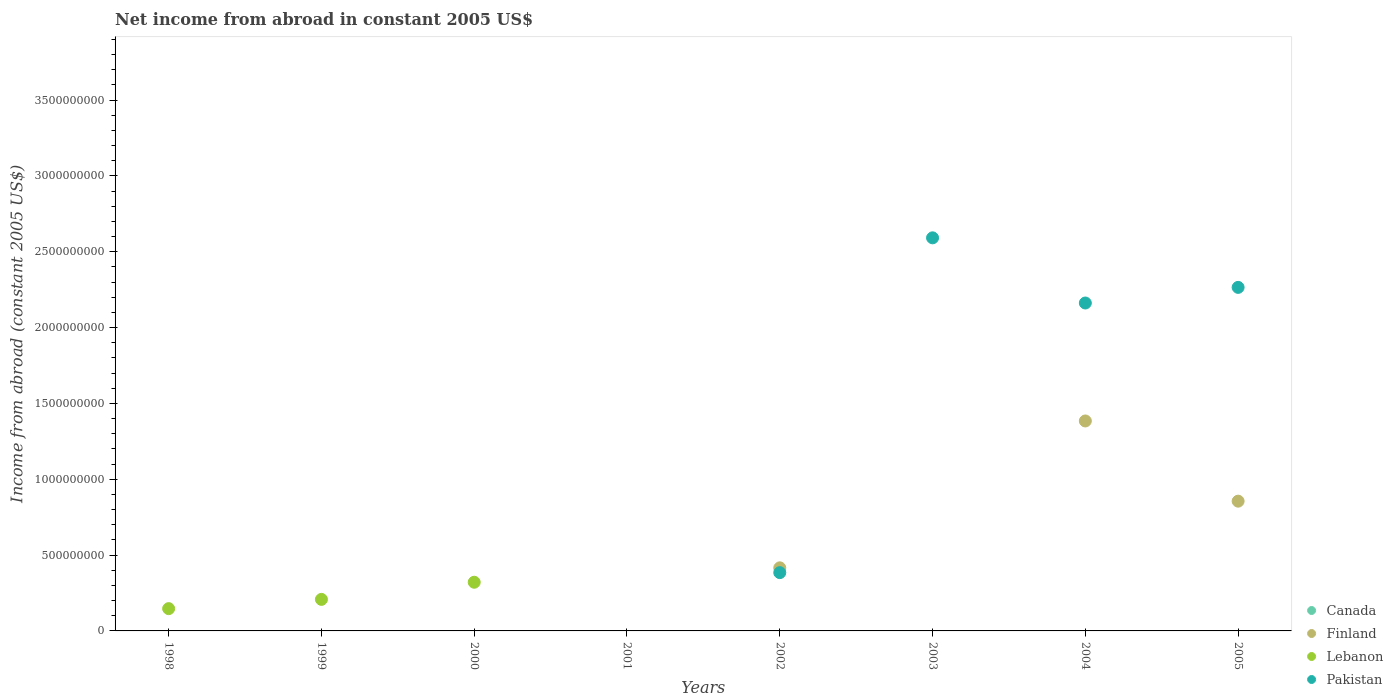How many different coloured dotlines are there?
Give a very brief answer. 3. Across all years, what is the maximum net income from abroad in Lebanon?
Provide a short and direct response. 3.21e+08. In which year was the net income from abroad in Lebanon maximum?
Make the answer very short. 2000. What is the difference between the net income from abroad in Canada in 2003 and the net income from abroad in Lebanon in 2001?
Offer a very short reply. 0. What is the average net income from abroad in Lebanon per year?
Provide a succinct answer. 8.45e+07. In the year 2005, what is the difference between the net income from abroad in Finland and net income from abroad in Pakistan?
Your response must be concise. -1.41e+09. Is the difference between the net income from abroad in Finland in 2002 and 2004 greater than the difference between the net income from abroad in Pakistan in 2002 and 2004?
Your response must be concise. Yes. What is the difference between the highest and the second highest net income from abroad in Lebanon?
Your answer should be compact. 1.13e+08. What is the difference between the highest and the lowest net income from abroad in Lebanon?
Ensure brevity in your answer.  3.21e+08. Is the net income from abroad in Pakistan strictly greater than the net income from abroad in Lebanon over the years?
Make the answer very short. No. Is the net income from abroad in Pakistan strictly less than the net income from abroad in Lebanon over the years?
Keep it short and to the point. No. How many years are there in the graph?
Your response must be concise. 8. What is the difference between two consecutive major ticks on the Y-axis?
Keep it short and to the point. 5.00e+08. Are the values on the major ticks of Y-axis written in scientific E-notation?
Make the answer very short. No. Does the graph contain grids?
Provide a succinct answer. No. How many legend labels are there?
Ensure brevity in your answer.  4. How are the legend labels stacked?
Give a very brief answer. Vertical. What is the title of the graph?
Your answer should be very brief. Net income from abroad in constant 2005 US$. Does "Niger" appear as one of the legend labels in the graph?
Your response must be concise. No. What is the label or title of the Y-axis?
Give a very brief answer. Income from abroad (constant 2005 US$). What is the Income from abroad (constant 2005 US$) in Lebanon in 1998?
Offer a very short reply. 1.47e+08. What is the Income from abroad (constant 2005 US$) of Canada in 1999?
Offer a terse response. 0. What is the Income from abroad (constant 2005 US$) of Finland in 1999?
Give a very brief answer. 0. What is the Income from abroad (constant 2005 US$) of Lebanon in 1999?
Provide a succinct answer. 2.08e+08. What is the Income from abroad (constant 2005 US$) of Pakistan in 1999?
Your answer should be very brief. 0. What is the Income from abroad (constant 2005 US$) in Lebanon in 2000?
Ensure brevity in your answer.  3.21e+08. What is the Income from abroad (constant 2005 US$) in Canada in 2001?
Ensure brevity in your answer.  0. What is the Income from abroad (constant 2005 US$) of Finland in 2001?
Offer a terse response. 0. What is the Income from abroad (constant 2005 US$) of Lebanon in 2001?
Provide a short and direct response. 0. What is the Income from abroad (constant 2005 US$) in Finland in 2002?
Ensure brevity in your answer.  4.16e+08. What is the Income from abroad (constant 2005 US$) of Pakistan in 2002?
Ensure brevity in your answer.  3.84e+08. What is the Income from abroad (constant 2005 US$) of Canada in 2003?
Make the answer very short. 0. What is the Income from abroad (constant 2005 US$) in Pakistan in 2003?
Keep it short and to the point. 2.59e+09. What is the Income from abroad (constant 2005 US$) in Finland in 2004?
Keep it short and to the point. 1.38e+09. What is the Income from abroad (constant 2005 US$) in Pakistan in 2004?
Your response must be concise. 2.16e+09. What is the Income from abroad (constant 2005 US$) of Finland in 2005?
Ensure brevity in your answer.  8.56e+08. What is the Income from abroad (constant 2005 US$) in Lebanon in 2005?
Your answer should be very brief. 0. What is the Income from abroad (constant 2005 US$) in Pakistan in 2005?
Offer a terse response. 2.27e+09. Across all years, what is the maximum Income from abroad (constant 2005 US$) of Finland?
Offer a very short reply. 1.38e+09. Across all years, what is the maximum Income from abroad (constant 2005 US$) in Lebanon?
Your answer should be compact. 3.21e+08. Across all years, what is the maximum Income from abroad (constant 2005 US$) of Pakistan?
Provide a short and direct response. 2.59e+09. Across all years, what is the minimum Income from abroad (constant 2005 US$) in Finland?
Offer a terse response. 0. Across all years, what is the minimum Income from abroad (constant 2005 US$) in Lebanon?
Your answer should be very brief. 0. Across all years, what is the minimum Income from abroad (constant 2005 US$) in Pakistan?
Make the answer very short. 0. What is the total Income from abroad (constant 2005 US$) in Finland in the graph?
Provide a succinct answer. 2.66e+09. What is the total Income from abroad (constant 2005 US$) of Lebanon in the graph?
Offer a terse response. 6.76e+08. What is the total Income from abroad (constant 2005 US$) of Pakistan in the graph?
Ensure brevity in your answer.  7.40e+09. What is the difference between the Income from abroad (constant 2005 US$) in Lebanon in 1998 and that in 1999?
Your answer should be compact. -6.10e+07. What is the difference between the Income from abroad (constant 2005 US$) of Lebanon in 1998 and that in 2000?
Provide a succinct answer. -1.74e+08. What is the difference between the Income from abroad (constant 2005 US$) of Lebanon in 1999 and that in 2000?
Provide a succinct answer. -1.13e+08. What is the difference between the Income from abroad (constant 2005 US$) of Pakistan in 2002 and that in 2003?
Give a very brief answer. -2.21e+09. What is the difference between the Income from abroad (constant 2005 US$) in Finland in 2002 and that in 2004?
Your answer should be very brief. -9.68e+08. What is the difference between the Income from abroad (constant 2005 US$) in Pakistan in 2002 and that in 2004?
Ensure brevity in your answer.  -1.78e+09. What is the difference between the Income from abroad (constant 2005 US$) in Finland in 2002 and that in 2005?
Offer a terse response. -4.40e+08. What is the difference between the Income from abroad (constant 2005 US$) of Pakistan in 2002 and that in 2005?
Your answer should be compact. -1.88e+09. What is the difference between the Income from abroad (constant 2005 US$) in Pakistan in 2003 and that in 2004?
Give a very brief answer. 4.30e+08. What is the difference between the Income from abroad (constant 2005 US$) of Pakistan in 2003 and that in 2005?
Make the answer very short. 3.27e+08. What is the difference between the Income from abroad (constant 2005 US$) in Finland in 2004 and that in 2005?
Give a very brief answer. 5.29e+08. What is the difference between the Income from abroad (constant 2005 US$) in Pakistan in 2004 and that in 2005?
Your answer should be compact. -1.03e+08. What is the difference between the Income from abroad (constant 2005 US$) in Lebanon in 1998 and the Income from abroad (constant 2005 US$) in Pakistan in 2002?
Make the answer very short. -2.37e+08. What is the difference between the Income from abroad (constant 2005 US$) in Lebanon in 1998 and the Income from abroad (constant 2005 US$) in Pakistan in 2003?
Keep it short and to the point. -2.44e+09. What is the difference between the Income from abroad (constant 2005 US$) in Lebanon in 1998 and the Income from abroad (constant 2005 US$) in Pakistan in 2004?
Your answer should be compact. -2.02e+09. What is the difference between the Income from abroad (constant 2005 US$) in Lebanon in 1998 and the Income from abroad (constant 2005 US$) in Pakistan in 2005?
Make the answer very short. -2.12e+09. What is the difference between the Income from abroad (constant 2005 US$) of Lebanon in 1999 and the Income from abroad (constant 2005 US$) of Pakistan in 2002?
Provide a short and direct response. -1.76e+08. What is the difference between the Income from abroad (constant 2005 US$) of Lebanon in 1999 and the Income from abroad (constant 2005 US$) of Pakistan in 2003?
Keep it short and to the point. -2.38e+09. What is the difference between the Income from abroad (constant 2005 US$) of Lebanon in 1999 and the Income from abroad (constant 2005 US$) of Pakistan in 2004?
Make the answer very short. -1.95e+09. What is the difference between the Income from abroad (constant 2005 US$) in Lebanon in 1999 and the Income from abroad (constant 2005 US$) in Pakistan in 2005?
Keep it short and to the point. -2.06e+09. What is the difference between the Income from abroad (constant 2005 US$) of Lebanon in 2000 and the Income from abroad (constant 2005 US$) of Pakistan in 2002?
Your answer should be compact. -6.33e+07. What is the difference between the Income from abroad (constant 2005 US$) of Lebanon in 2000 and the Income from abroad (constant 2005 US$) of Pakistan in 2003?
Ensure brevity in your answer.  -2.27e+09. What is the difference between the Income from abroad (constant 2005 US$) in Lebanon in 2000 and the Income from abroad (constant 2005 US$) in Pakistan in 2004?
Ensure brevity in your answer.  -1.84e+09. What is the difference between the Income from abroad (constant 2005 US$) in Lebanon in 2000 and the Income from abroad (constant 2005 US$) in Pakistan in 2005?
Provide a short and direct response. -1.94e+09. What is the difference between the Income from abroad (constant 2005 US$) in Finland in 2002 and the Income from abroad (constant 2005 US$) in Pakistan in 2003?
Ensure brevity in your answer.  -2.18e+09. What is the difference between the Income from abroad (constant 2005 US$) in Finland in 2002 and the Income from abroad (constant 2005 US$) in Pakistan in 2004?
Provide a short and direct response. -1.75e+09. What is the difference between the Income from abroad (constant 2005 US$) in Finland in 2002 and the Income from abroad (constant 2005 US$) in Pakistan in 2005?
Your answer should be very brief. -1.85e+09. What is the difference between the Income from abroad (constant 2005 US$) in Finland in 2004 and the Income from abroad (constant 2005 US$) in Pakistan in 2005?
Ensure brevity in your answer.  -8.81e+08. What is the average Income from abroad (constant 2005 US$) of Finland per year?
Ensure brevity in your answer.  3.32e+08. What is the average Income from abroad (constant 2005 US$) of Lebanon per year?
Keep it short and to the point. 8.45e+07. What is the average Income from abroad (constant 2005 US$) of Pakistan per year?
Keep it short and to the point. 9.25e+08. In the year 2002, what is the difference between the Income from abroad (constant 2005 US$) of Finland and Income from abroad (constant 2005 US$) of Pakistan?
Your answer should be compact. 3.17e+07. In the year 2004, what is the difference between the Income from abroad (constant 2005 US$) in Finland and Income from abroad (constant 2005 US$) in Pakistan?
Ensure brevity in your answer.  -7.78e+08. In the year 2005, what is the difference between the Income from abroad (constant 2005 US$) of Finland and Income from abroad (constant 2005 US$) of Pakistan?
Make the answer very short. -1.41e+09. What is the ratio of the Income from abroad (constant 2005 US$) of Lebanon in 1998 to that in 1999?
Provide a succinct answer. 0.71. What is the ratio of the Income from abroad (constant 2005 US$) in Lebanon in 1998 to that in 2000?
Keep it short and to the point. 0.46. What is the ratio of the Income from abroad (constant 2005 US$) in Lebanon in 1999 to that in 2000?
Make the answer very short. 0.65. What is the ratio of the Income from abroad (constant 2005 US$) in Pakistan in 2002 to that in 2003?
Ensure brevity in your answer.  0.15. What is the ratio of the Income from abroad (constant 2005 US$) of Finland in 2002 to that in 2004?
Your answer should be compact. 0.3. What is the ratio of the Income from abroad (constant 2005 US$) in Pakistan in 2002 to that in 2004?
Your answer should be compact. 0.18. What is the ratio of the Income from abroad (constant 2005 US$) of Finland in 2002 to that in 2005?
Your response must be concise. 0.49. What is the ratio of the Income from abroad (constant 2005 US$) in Pakistan in 2002 to that in 2005?
Your response must be concise. 0.17. What is the ratio of the Income from abroad (constant 2005 US$) in Pakistan in 2003 to that in 2004?
Give a very brief answer. 1.2. What is the ratio of the Income from abroad (constant 2005 US$) in Pakistan in 2003 to that in 2005?
Provide a short and direct response. 1.14. What is the ratio of the Income from abroad (constant 2005 US$) of Finland in 2004 to that in 2005?
Keep it short and to the point. 1.62. What is the ratio of the Income from abroad (constant 2005 US$) of Pakistan in 2004 to that in 2005?
Your response must be concise. 0.95. What is the difference between the highest and the second highest Income from abroad (constant 2005 US$) of Finland?
Your answer should be compact. 5.29e+08. What is the difference between the highest and the second highest Income from abroad (constant 2005 US$) of Lebanon?
Your answer should be very brief. 1.13e+08. What is the difference between the highest and the second highest Income from abroad (constant 2005 US$) in Pakistan?
Offer a very short reply. 3.27e+08. What is the difference between the highest and the lowest Income from abroad (constant 2005 US$) in Finland?
Your answer should be compact. 1.38e+09. What is the difference between the highest and the lowest Income from abroad (constant 2005 US$) in Lebanon?
Offer a terse response. 3.21e+08. What is the difference between the highest and the lowest Income from abroad (constant 2005 US$) of Pakistan?
Offer a terse response. 2.59e+09. 